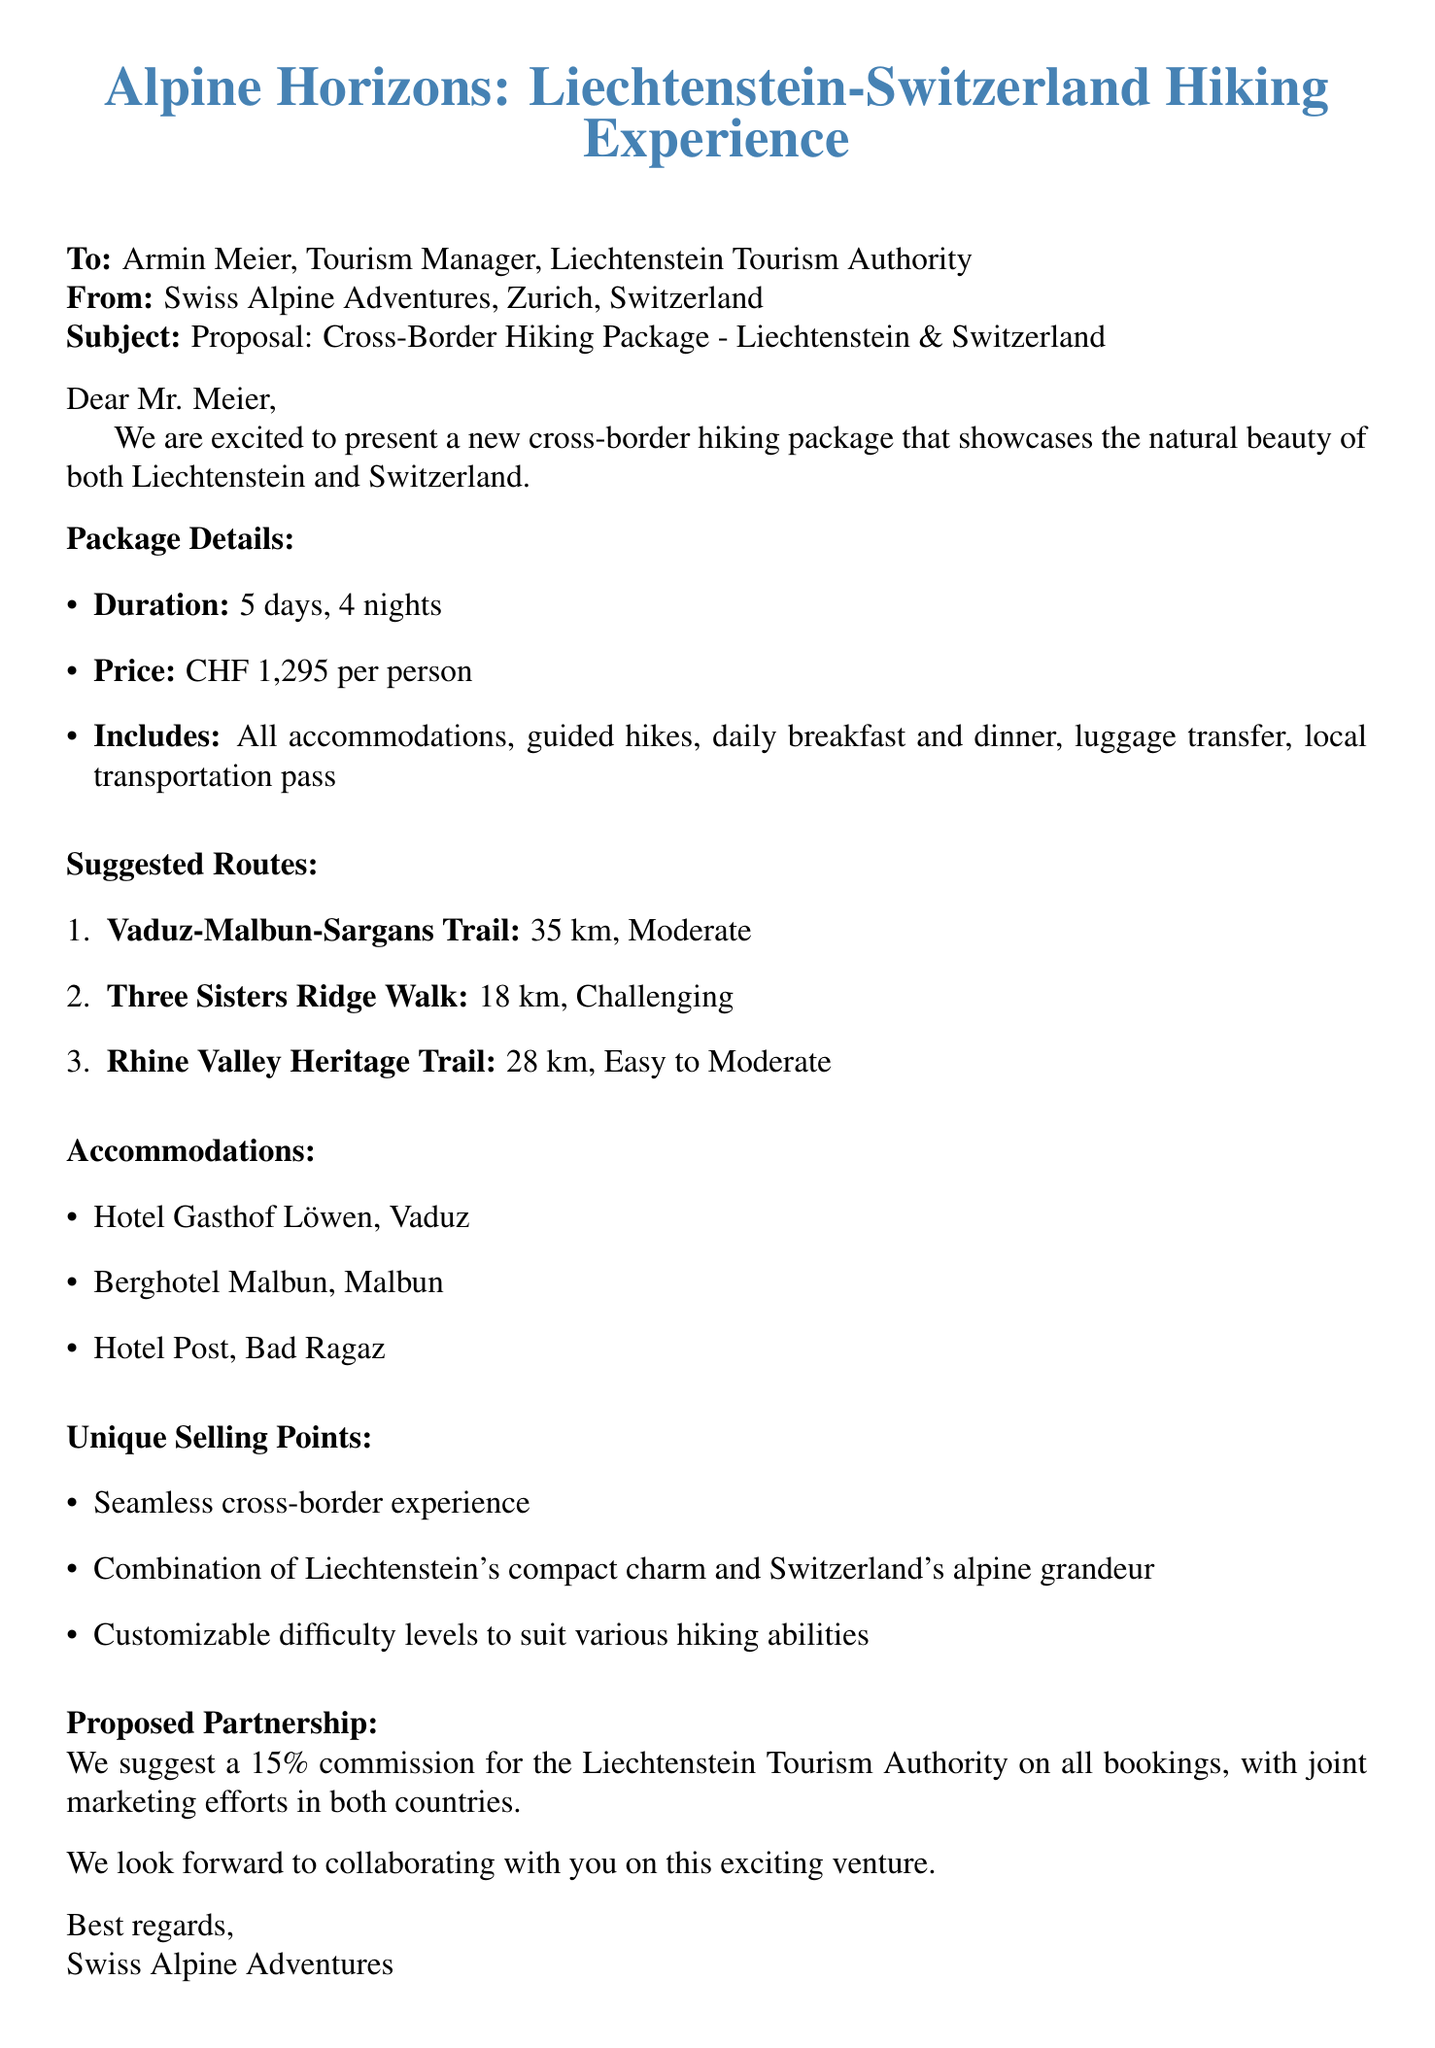What is the name of the hiking package? The name of the hiking package is mentioned in the introduction of the document.
Answer: Alpine Horizons: Liechtenstein-Switzerland Hiking Experience How many days does the hiking package last? The duration of the package is clearly stated in the document.
Answer: 5 days, 4 nights What is the total distance of the Vaduz-Malbun-Sargans Trail? The distance for this specific trail is provided in the suggested routes section.
Answer: 35 km What is included in the package price? The document lists the inclusions under the pricing section.
Answer: All accommodations, guided hikes, breakfast and dinner daily, luggage transfer between hotels, local transportation pass What is the suggested commission for the Liechtenstein Tourism Authority? The proposed partnership section specifies this commission.
Answer: 15% What is the difficulty level of the Three Sisters Ridge Walk? The difficulty level is for this hike is stated under the suggested routes section.
Answer: Challenging Where can participants stay in Vaduz? The accommodations section provides specific hotel names for Vaduz.
Answer: Hotel Gasthof Löwen, Vaduz Can the package be customized for different hiking abilities? This is mentioned in the unique selling points of the document.
Answer: Yes What is the primary theme of the hiking package? The introduction provides a hint about the main focus of the package.
Answer: Natural beauty of both Liechtenstein and Switzerland 